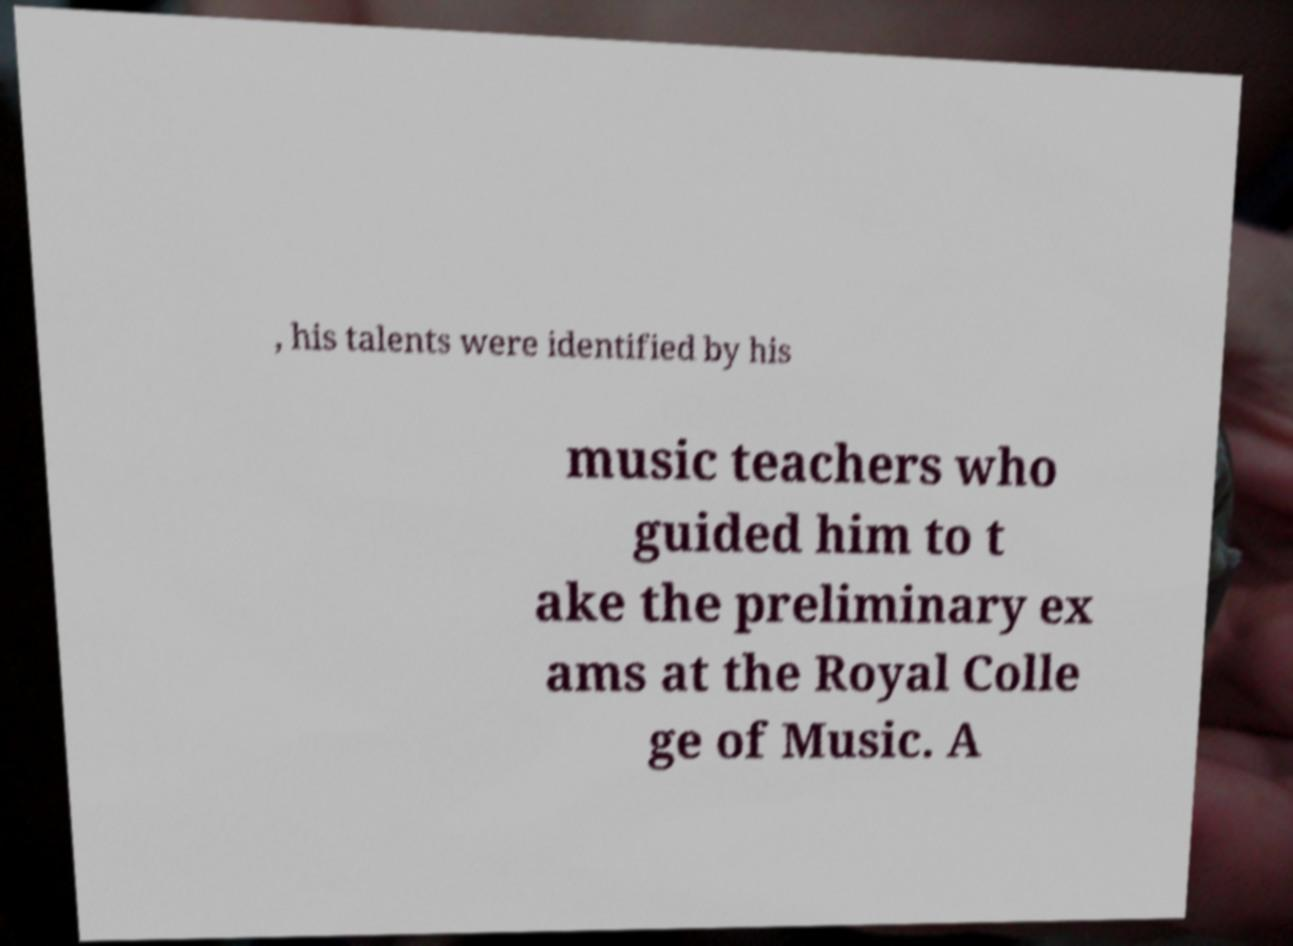What messages or text are displayed in this image? I need them in a readable, typed format. , his talents were identified by his music teachers who guided him to t ake the preliminary ex ams at the Royal Colle ge of Music. A 